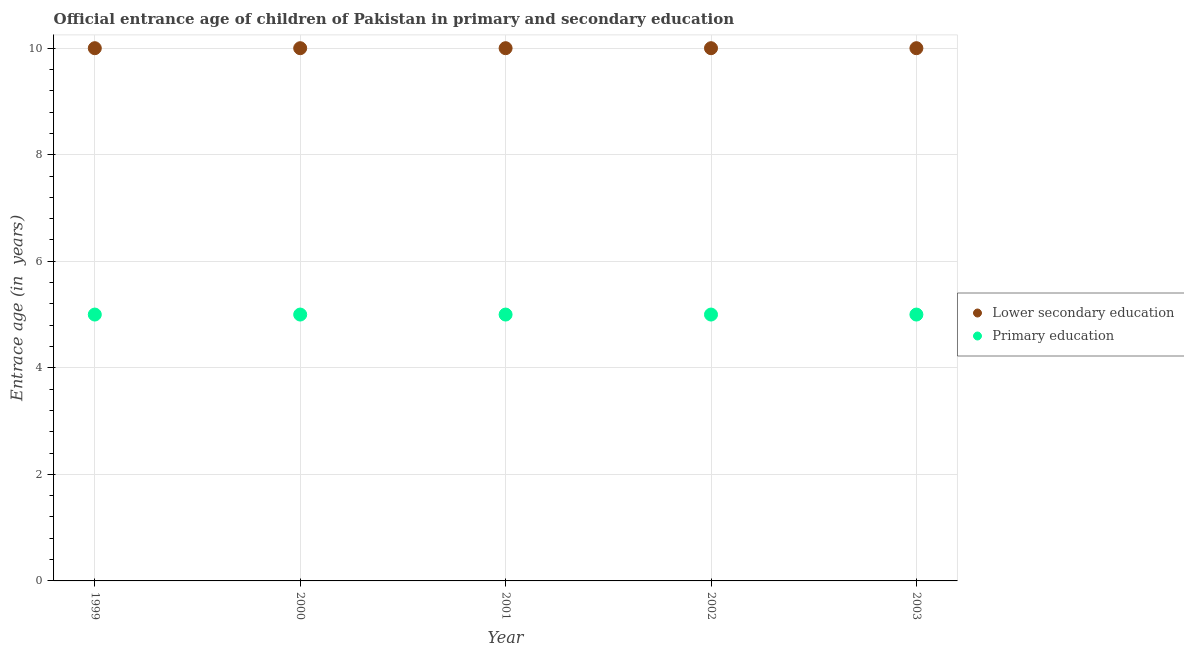Is the number of dotlines equal to the number of legend labels?
Provide a short and direct response. Yes. What is the entrance age of children in lower secondary education in 2002?
Your answer should be compact. 10. Across all years, what is the maximum entrance age of children in lower secondary education?
Give a very brief answer. 10. Across all years, what is the minimum entrance age of children in lower secondary education?
Provide a short and direct response. 10. What is the total entrance age of chiildren in primary education in the graph?
Provide a short and direct response. 25. What is the difference between the entrance age of children in lower secondary education in 2001 and that in 2003?
Your answer should be compact. 0. What is the difference between the entrance age of chiildren in primary education in 2001 and the entrance age of children in lower secondary education in 2000?
Your answer should be compact. -5. In the year 2000, what is the difference between the entrance age of chiildren in primary education and entrance age of children in lower secondary education?
Make the answer very short. -5. In how many years, is the entrance age of children in lower secondary education greater than 0.4 years?
Keep it short and to the point. 5. What is the ratio of the entrance age of children in lower secondary education in 2001 to that in 2002?
Provide a short and direct response. 1. What is the difference between the highest and the second highest entrance age of chiildren in primary education?
Keep it short and to the point. 0. What is the difference between the highest and the lowest entrance age of children in lower secondary education?
Your answer should be very brief. 0. Is the sum of the entrance age of children in lower secondary education in 2001 and 2002 greater than the maximum entrance age of chiildren in primary education across all years?
Offer a terse response. Yes. Is the entrance age of children in lower secondary education strictly greater than the entrance age of chiildren in primary education over the years?
Keep it short and to the point. Yes. Is the entrance age of children in lower secondary education strictly less than the entrance age of chiildren in primary education over the years?
Your answer should be very brief. No. How many dotlines are there?
Ensure brevity in your answer.  2. How many years are there in the graph?
Make the answer very short. 5. What is the difference between two consecutive major ticks on the Y-axis?
Make the answer very short. 2. Are the values on the major ticks of Y-axis written in scientific E-notation?
Ensure brevity in your answer.  No. Does the graph contain grids?
Ensure brevity in your answer.  Yes. What is the title of the graph?
Offer a very short reply. Official entrance age of children of Pakistan in primary and secondary education. Does "Research and Development" appear as one of the legend labels in the graph?
Keep it short and to the point. No. What is the label or title of the Y-axis?
Provide a succinct answer. Entrace age (in  years). What is the Entrace age (in  years) of Primary education in 1999?
Offer a very short reply. 5. What is the Entrace age (in  years) of Primary education in 2000?
Your answer should be very brief. 5. What is the Entrace age (in  years) in Primary education in 2001?
Keep it short and to the point. 5. What is the Entrace age (in  years) of Lower secondary education in 2002?
Provide a short and direct response. 10. What is the Entrace age (in  years) of Lower secondary education in 2003?
Give a very brief answer. 10. Across all years, what is the minimum Entrace age (in  years) of Lower secondary education?
Provide a succinct answer. 10. What is the difference between the Entrace age (in  years) of Primary education in 1999 and that in 2001?
Ensure brevity in your answer.  0. What is the difference between the Entrace age (in  years) in Lower secondary education in 1999 and that in 2003?
Provide a succinct answer. 0. What is the difference between the Entrace age (in  years) in Primary education in 1999 and that in 2003?
Provide a succinct answer. 0. What is the difference between the Entrace age (in  years) in Primary education in 2000 and that in 2001?
Give a very brief answer. 0. What is the difference between the Entrace age (in  years) of Lower secondary education in 2000 and that in 2002?
Provide a succinct answer. 0. What is the difference between the Entrace age (in  years) in Lower secondary education in 2000 and that in 2003?
Give a very brief answer. 0. What is the difference between the Entrace age (in  years) of Primary education in 2001 and that in 2002?
Offer a very short reply. 0. What is the difference between the Entrace age (in  years) of Primary education in 2002 and that in 2003?
Your response must be concise. 0. What is the difference between the Entrace age (in  years) in Lower secondary education in 1999 and the Entrace age (in  years) in Primary education in 2001?
Provide a succinct answer. 5. What is the difference between the Entrace age (in  years) in Lower secondary education in 2000 and the Entrace age (in  years) in Primary education in 2001?
Provide a succinct answer. 5. What is the difference between the Entrace age (in  years) in Lower secondary education in 2000 and the Entrace age (in  years) in Primary education in 2003?
Your answer should be very brief. 5. What is the difference between the Entrace age (in  years) in Lower secondary education in 2002 and the Entrace age (in  years) in Primary education in 2003?
Your answer should be very brief. 5. What is the average Entrace age (in  years) in Lower secondary education per year?
Keep it short and to the point. 10. What is the average Entrace age (in  years) in Primary education per year?
Offer a very short reply. 5. In the year 1999, what is the difference between the Entrace age (in  years) of Lower secondary education and Entrace age (in  years) of Primary education?
Your response must be concise. 5. In the year 2000, what is the difference between the Entrace age (in  years) of Lower secondary education and Entrace age (in  years) of Primary education?
Give a very brief answer. 5. In the year 2001, what is the difference between the Entrace age (in  years) of Lower secondary education and Entrace age (in  years) of Primary education?
Ensure brevity in your answer.  5. What is the ratio of the Entrace age (in  years) of Lower secondary education in 1999 to that in 2000?
Provide a short and direct response. 1. What is the ratio of the Entrace age (in  years) in Primary education in 1999 to that in 2001?
Offer a terse response. 1. What is the ratio of the Entrace age (in  years) of Lower secondary education in 1999 to that in 2002?
Offer a terse response. 1. What is the ratio of the Entrace age (in  years) in Lower secondary education in 1999 to that in 2003?
Ensure brevity in your answer.  1. What is the ratio of the Entrace age (in  years) in Primary education in 1999 to that in 2003?
Keep it short and to the point. 1. What is the ratio of the Entrace age (in  years) in Primary education in 2000 to that in 2002?
Your answer should be very brief. 1. What is the ratio of the Entrace age (in  years) in Lower secondary education in 2000 to that in 2003?
Ensure brevity in your answer.  1. What is the ratio of the Entrace age (in  years) of Primary education in 2000 to that in 2003?
Give a very brief answer. 1. What is the ratio of the Entrace age (in  years) in Lower secondary education in 2001 to that in 2003?
Make the answer very short. 1. What is the ratio of the Entrace age (in  years) in Primary education in 2001 to that in 2003?
Keep it short and to the point. 1. What is the ratio of the Entrace age (in  years) of Primary education in 2002 to that in 2003?
Provide a short and direct response. 1. What is the difference between the highest and the second highest Entrace age (in  years) of Lower secondary education?
Your answer should be compact. 0. What is the difference between the highest and the lowest Entrace age (in  years) in Lower secondary education?
Your response must be concise. 0. 